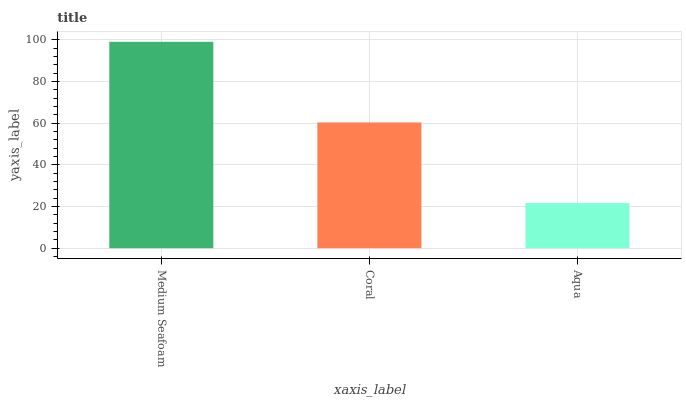Is Coral the minimum?
Answer yes or no. No. Is Coral the maximum?
Answer yes or no. No. Is Medium Seafoam greater than Coral?
Answer yes or no. Yes. Is Coral less than Medium Seafoam?
Answer yes or no. Yes. Is Coral greater than Medium Seafoam?
Answer yes or no. No. Is Medium Seafoam less than Coral?
Answer yes or no. No. Is Coral the high median?
Answer yes or no. Yes. Is Coral the low median?
Answer yes or no. Yes. Is Medium Seafoam the high median?
Answer yes or no. No. Is Aqua the low median?
Answer yes or no. No. 